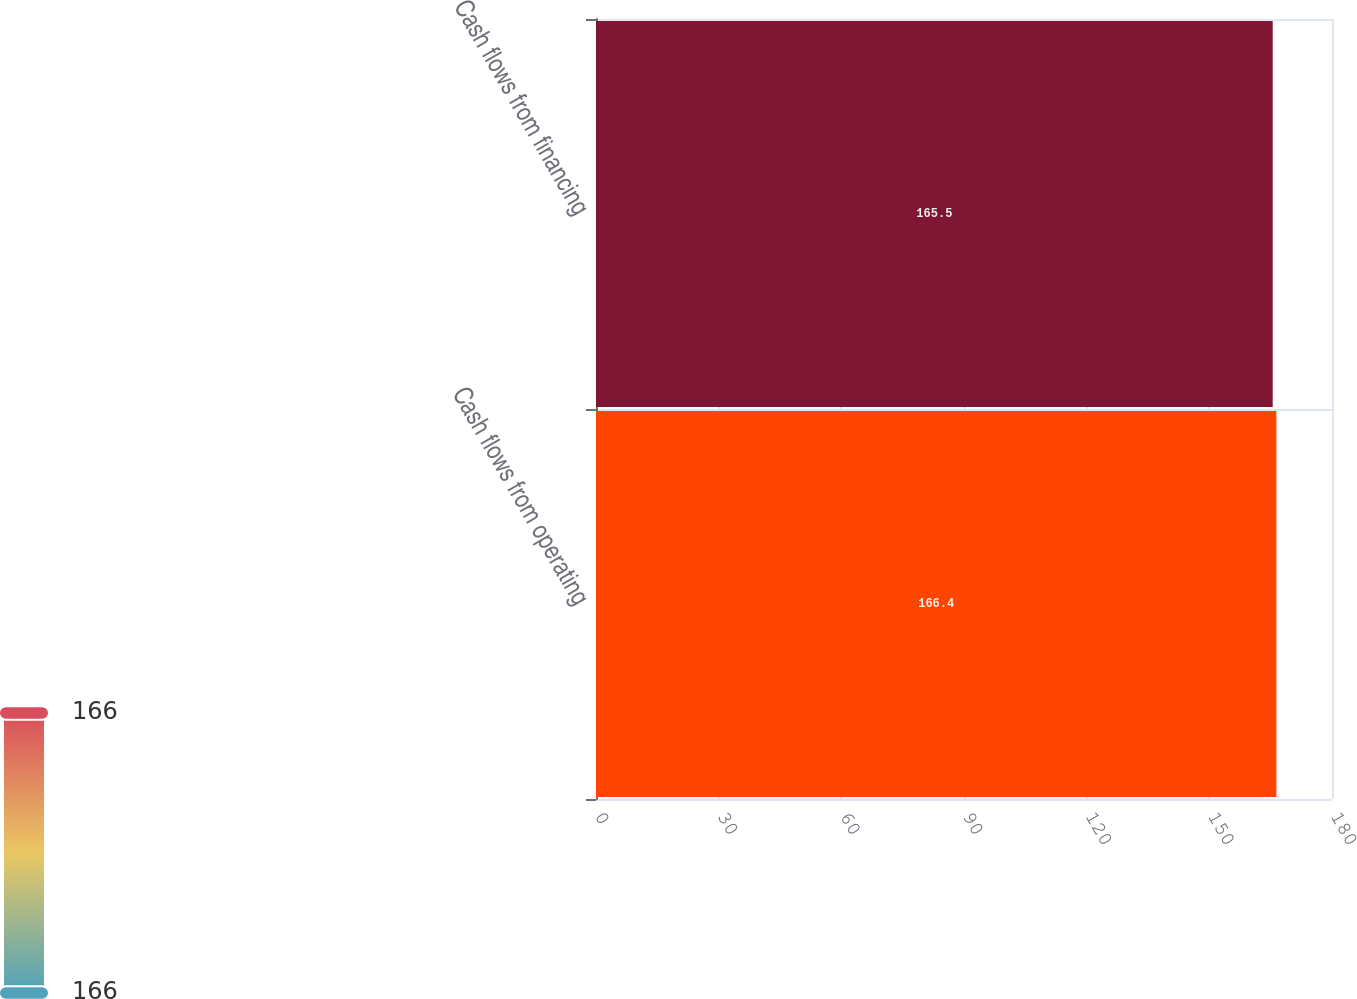Convert chart to OTSL. <chart><loc_0><loc_0><loc_500><loc_500><bar_chart><fcel>Cash flows from operating<fcel>Cash flows from financing<nl><fcel>166.4<fcel>165.5<nl></chart> 